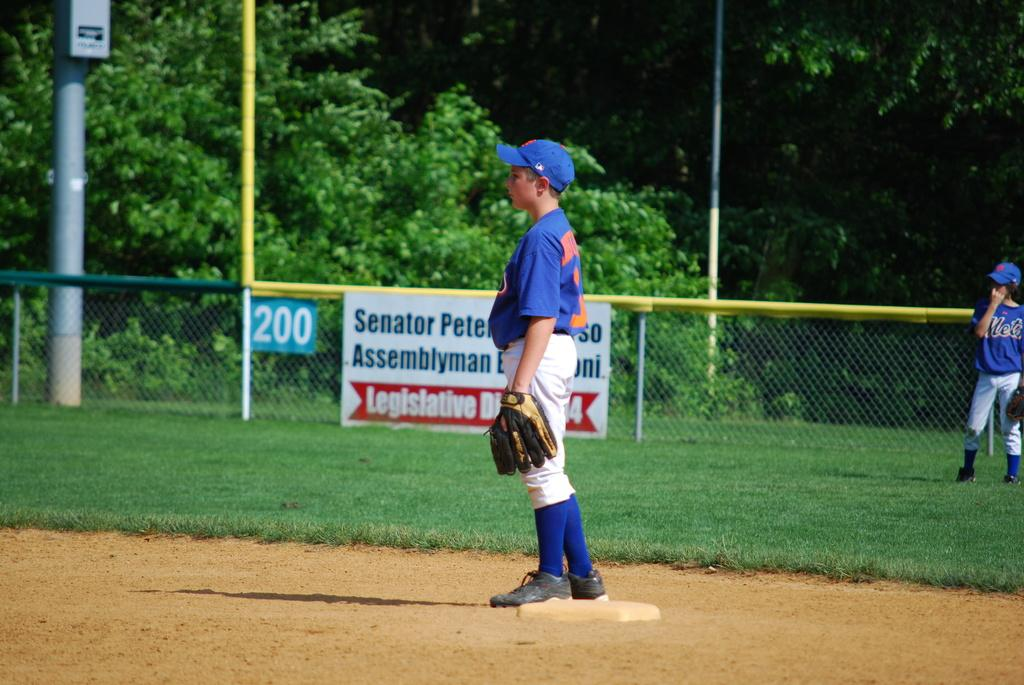<image>
Render a clear and concise summary of the photo. A baseball game is being played on a field with an advertisement visible for the Senator. 